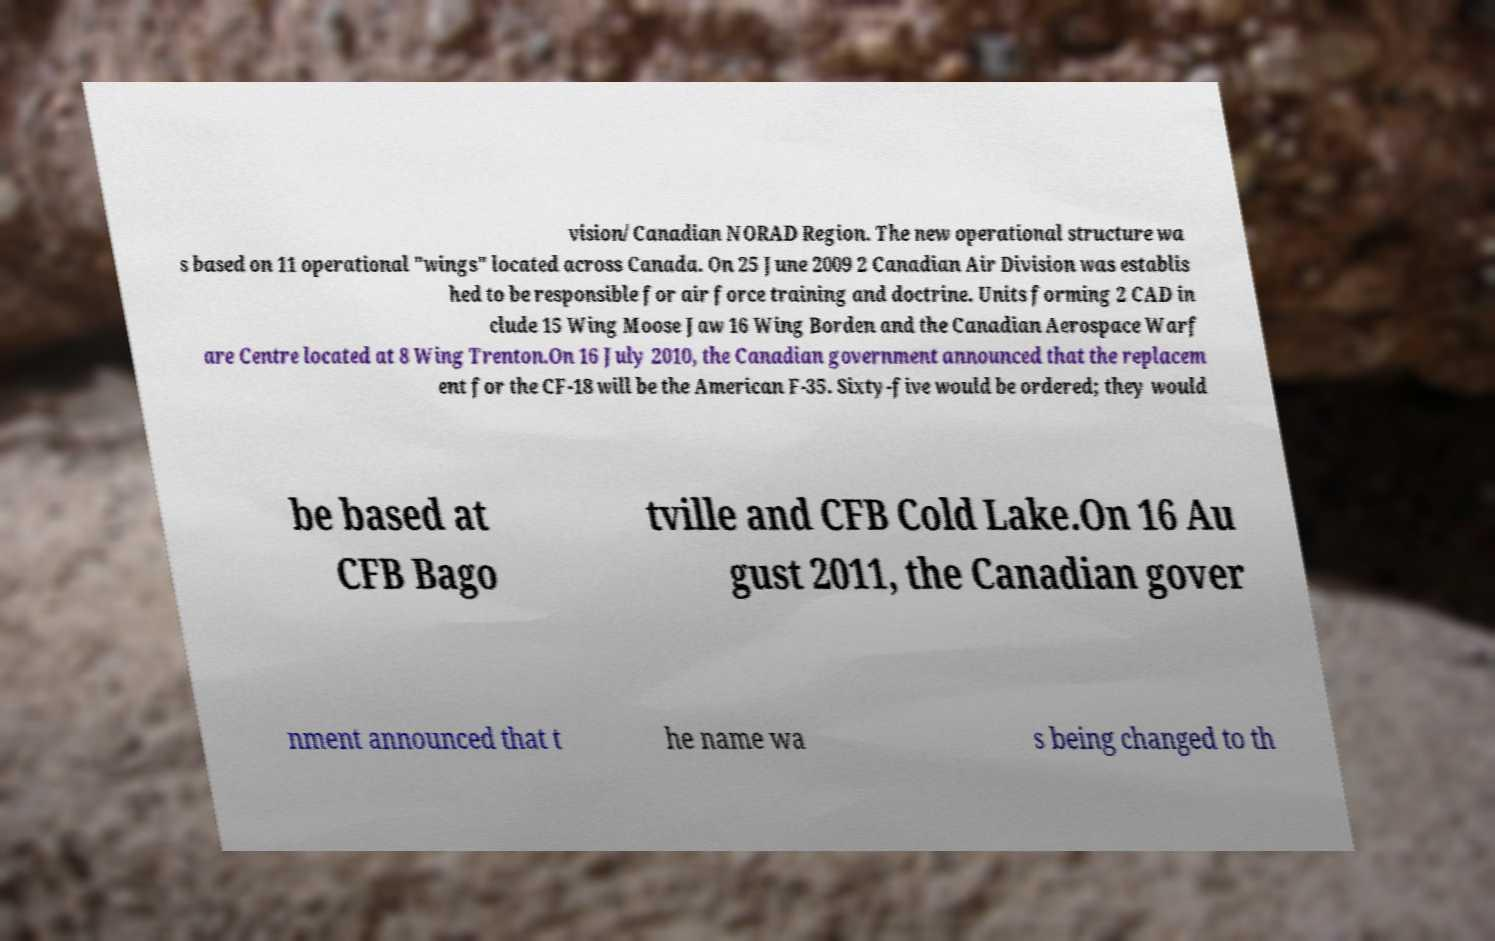There's text embedded in this image that I need extracted. Can you transcribe it verbatim? vision/Canadian NORAD Region. The new operational structure wa s based on 11 operational "wings" located across Canada. On 25 June 2009 2 Canadian Air Division was establis hed to be responsible for air force training and doctrine. Units forming 2 CAD in clude 15 Wing Moose Jaw 16 Wing Borden and the Canadian Aerospace Warf are Centre located at 8 Wing Trenton.On 16 July 2010, the Canadian government announced that the replacem ent for the CF-18 will be the American F-35. Sixty-five would be ordered; they would be based at CFB Bago tville and CFB Cold Lake.On 16 Au gust 2011, the Canadian gover nment announced that t he name wa s being changed to th 